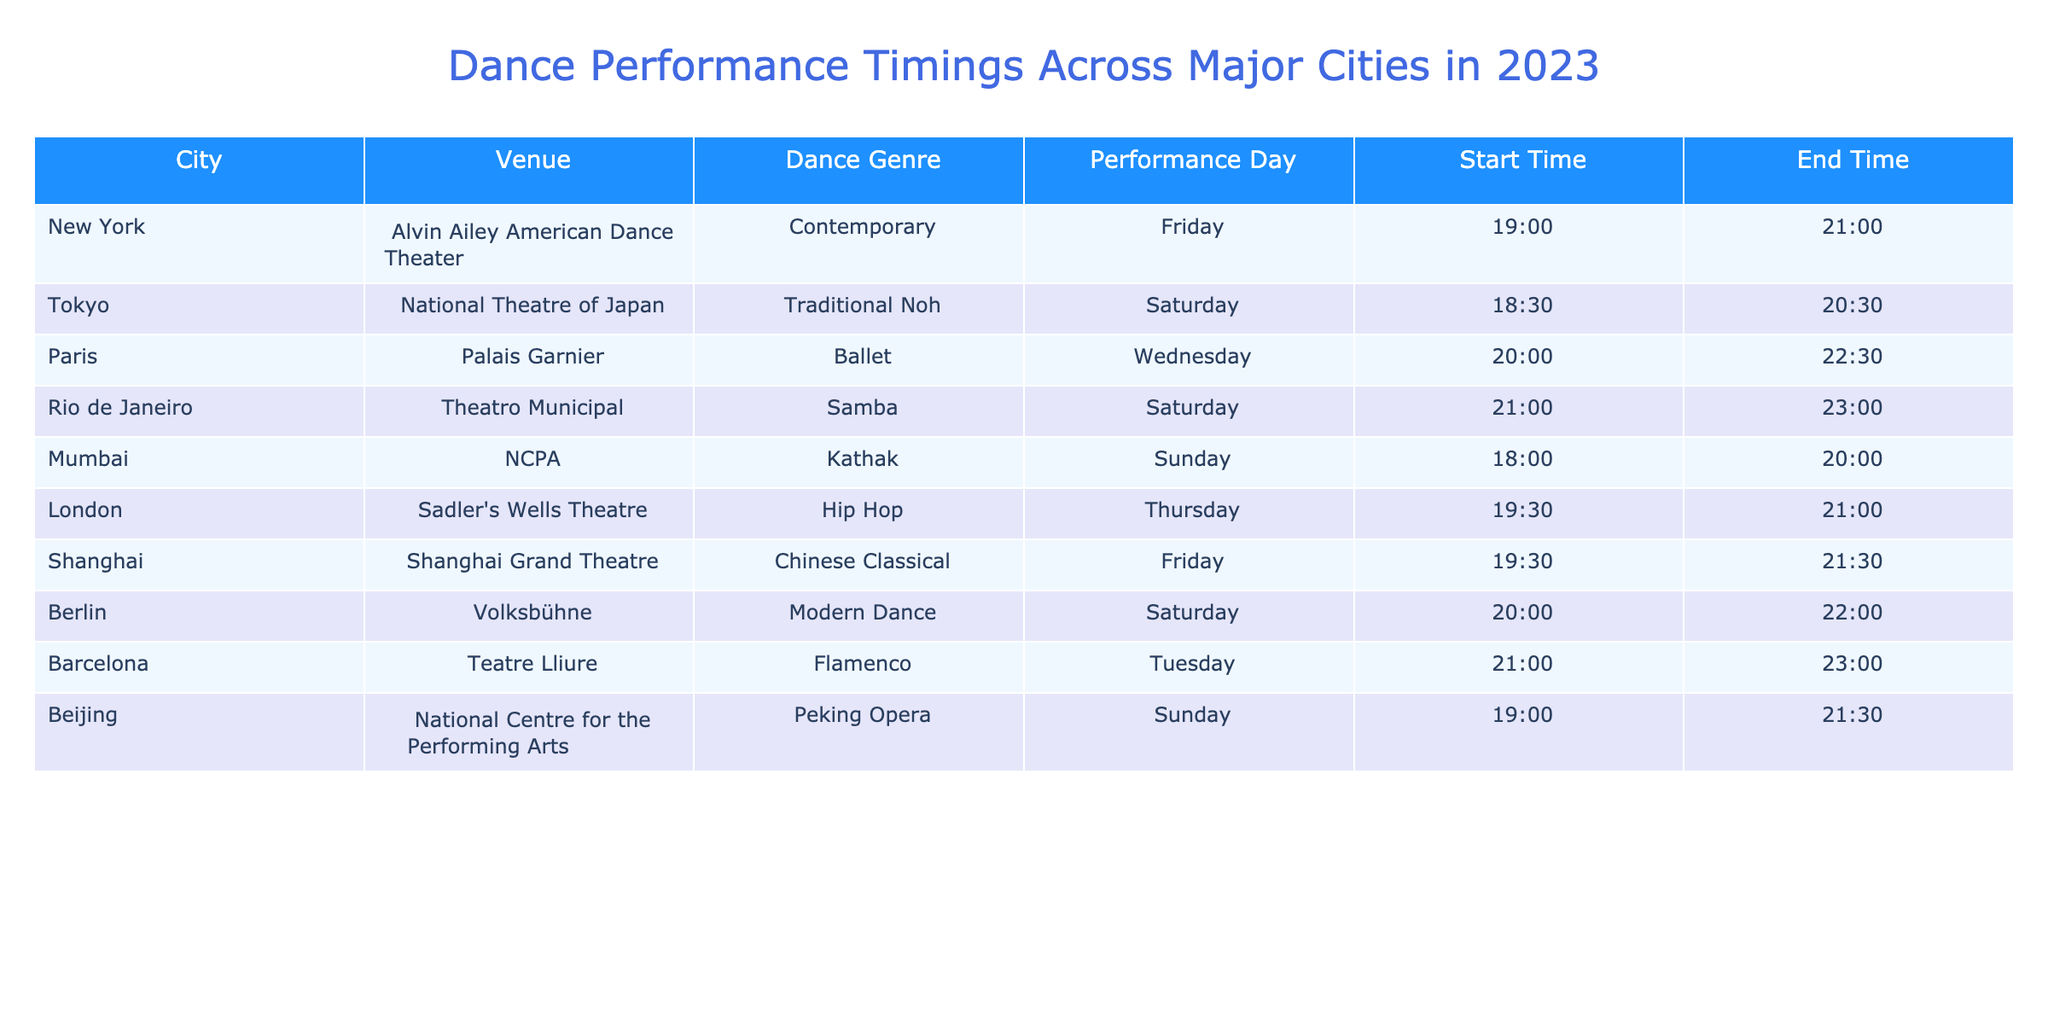What dance genre is performed at the Palais Garnier in Paris? The table indicates that the venue Palais Garnier hosts a Ballet performance. This can be directly retrieved from the "Dance Genre" column corresponding to the "City" and "Venue".
Answer: Ballet Which city has a performance that starts at 18:30 on Saturday? Referring to the table, Tokyo has a Traditional Noh performance that starts at 18:30 on Saturday. This can be confirmed by matching the "Start Time" with the "Performance Day" for each city.
Answer: Tokyo What is the end time of the performance at the NCPA in Mumbai? By looking at the table, the performance at NCPA in Mumbai ends at 20:00 on Sunday. This can be found easily in the column for "End Time".
Answer: 20:00 Is there a performance scheduled for Friday in Berlin? The table shows that Berlin has a Modern Dance performance scheduled on Saturday instead. Therefore, there is no performance on Friday in Berlin. This can be checked by examining the "Performance Day" for the city of Berlin.
Answer: No Which two cities have performances that overlap in time? Upon examining the performance timings, New York and Shanghai both have shows that start at 19:30 on Friday, which means they overlap in time. New York ends at 21:00, while Shanghai ends at 21:30. The overlapping is determined by the start time and end time of the performances listed in the respective rows.
Answer: New York and Shanghai How many performances take place on Saturday? The table lists performances for Tokyo, Rio de Janeiro, and Berlin on Saturday. Counting them gives a total of three performances, which involves reviewing the "Performance Day" column to find all instances of "Saturday".
Answer: 3 What is the total time duration for the Flamenco performance in Barcelona? The Flamenco performance in Barcelona starts at 21:00 and ends at 23:00. This gives a total duration of 2 hours (23:00 - 21:00 = 2 hours). Subtracting the start time from the end time provides this total duration.
Answer: 2 hours Which city has the earliest starting performance on Sunday? By assessing the performance times, Mumbai starts its Kathak performance at 18:00, while Beijing's Peking Opera starts at 19:00. Thus, Mumbai has the earliest starting time on Sunday. This requires comparison of start times on the same day across the data.
Answer: Mumbai Is the performance in London on a weekend? The table indicates that the performance in London occurs on Thursday, not over the weekend (Saturday or Sunday). This is ascertainable by checking the "Performance Day" for the London entry.
Answer: No 